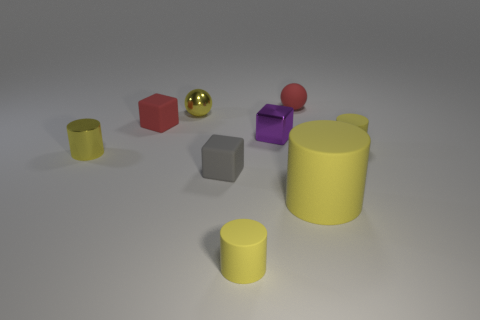There is a small rubber cylinder that is in front of the gray thing; is it the same color as the sphere that is on the left side of the tiny red rubber sphere?
Ensure brevity in your answer.  Yes. How many small metal things are on the right side of the tiny red cube?
Give a very brief answer. 2. How many other shiny things have the same color as the big object?
Provide a succinct answer. 2. Do the small gray cube on the left side of the small purple object and the tiny purple object have the same material?
Offer a very short reply. No. What number of purple cubes are the same material as the large thing?
Your answer should be very brief. 0. Is the number of tiny rubber blocks that are behind the small purple metallic thing greater than the number of matte cubes?
Your response must be concise. No. What is the size of the shiny cylinder that is the same color as the large matte thing?
Your answer should be very brief. Small. Are there any brown objects that have the same shape as the small gray rubber object?
Keep it short and to the point. No. How many things are yellow matte objects or green things?
Offer a terse response. 3. How many small red matte things are on the right side of the tiny yellow matte thing that is left of the tiny yellow matte thing behind the tiny gray object?
Give a very brief answer. 1. 